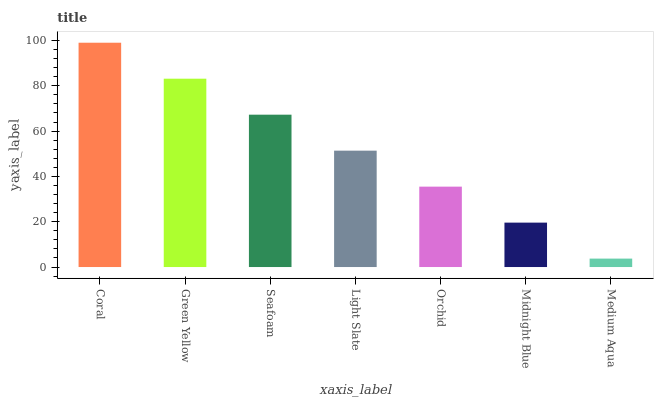Is Green Yellow the minimum?
Answer yes or no. No. Is Green Yellow the maximum?
Answer yes or no. No. Is Coral greater than Green Yellow?
Answer yes or no. Yes. Is Green Yellow less than Coral?
Answer yes or no. Yes. Is Green Yellow greater than Coral?
Answer yes or no. No. Is Coral less than Green Yellow?
Answer yes or no. No. Is Light Slate the high median?
Answer yes or no. Yes. Is Light Slate the low median?
Answer yes or no. Yes. Is Orchid the high median?
Answer yes or no. No. Is Midnight Blue the low median?
Answer yes or no. No. 